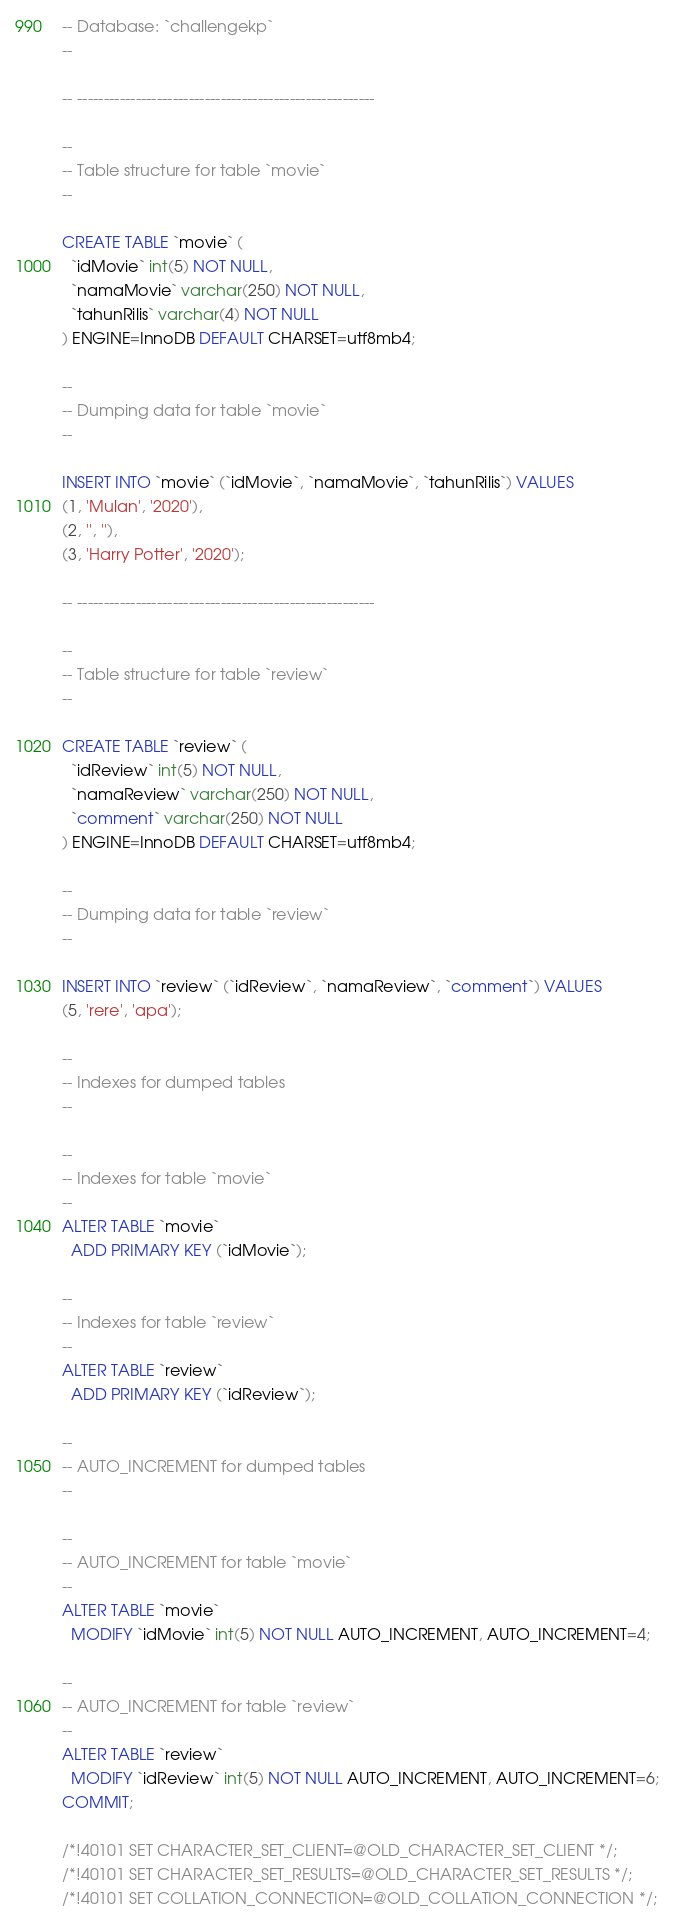<code> <loc_0><loc_0><loc_500><loc_500><_SQL_>-- Database: `challengekp`
--

-- --------------------------------------------------------

--
-- Table structure for table `movie`
--

CREATE TABLE `movie` (
  `idMovie` int(5) NOT NULL,
  `namaMovie` varchar(250) NOT NULL,
  `tahunRilis` varchar(4) NOT NULL
) ENGINE=InnoDB DEFAULT CHARSET=utf8mb4;

--
-- Dumping data for table `movie`
--

INSERT INTO `movie` (`idMovie`, `namaMovie`, `tahunRilis`) VALUES
(1, 'Mulan', '2020'),
(2, '', ''),
(3, 'Harry Potter', '2020');

-- --------------------------------------------------------

--
-- Table structure for table `review`
--

CREATE TABLE `review` (
  `idReview` int(5) NOT NULL,
  `namaReview` varchar(250) NOT NULL,
  `comment` varchar(250) NOT NULL
) ENGINE=InnoDB DEFAULT CHARSET=utf8mb4;

--
-- Dumping data for table `review`
--

INSERT INTO `review` (`idReview`, `namaReview`, `comment`) VALUES
(5, 'rere', 'apa');

--
-- Indexes for dumped tables
--

--
-- Indexes for table `movie`
--
ALTER TABLE `movie`
  ADD PRIMARY KEY (`idMovie`);

--
-- Indexes for table `review`
--
ALTER TABLE `review`
  ADD PRIMARY KEY (`idReview`);

--
-- AUTO_INCREMENT for dumped tables
--

--
-- AUTO_INCREMENT for table `movie`
--
ALTER TABLE `movie`
  MODIFY `idMovie` int(5) NOT NULL AUTO_INCREMENT, AUTO_INCREMENT=4;

--
-- AUTO_INCREMENT for table `review`
--
ALTER TABLE `review`
  MODIFY `idReview` int(5) NOT NULL AUTO_INCREMENT, AUTO_INCREMENT=6;
COMMIT;

/*!40101 SET CHARACTER_SET_CLIENT=@OLD_CHARACTER_SET_CLIENT */;
/*!40101 SET CHARACTER_SET_RESULTS=@OLD_CHARACTER_SET_RESULTS */;
/*!40101 SET COLLATION_CONNECTION=@OLD_COLLATION_CONNECTION */;
</code> 